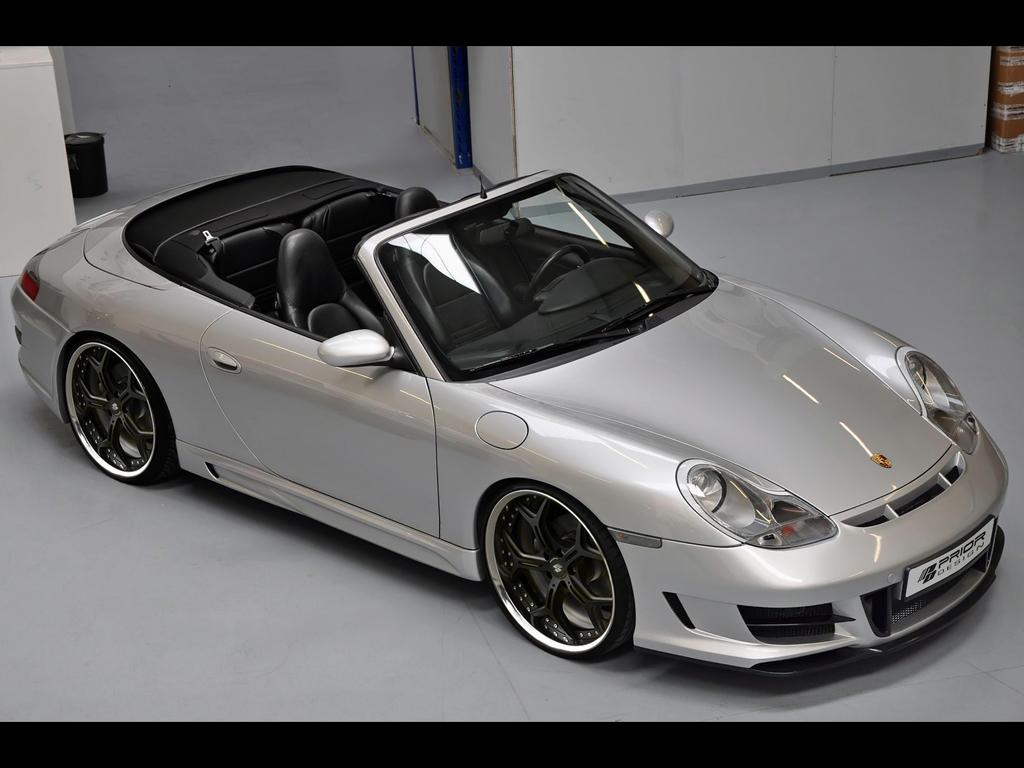What is the main object on the ground in the image? There is a car on the ground in the image. What is the color of the object in the image? There is a black color object in the image. What is the color of the wall in the image? There is a white color wall in the image. How many legs can be seen on the car in the image? Cars do not have legs, so there are no legs visible on the car in the image. 